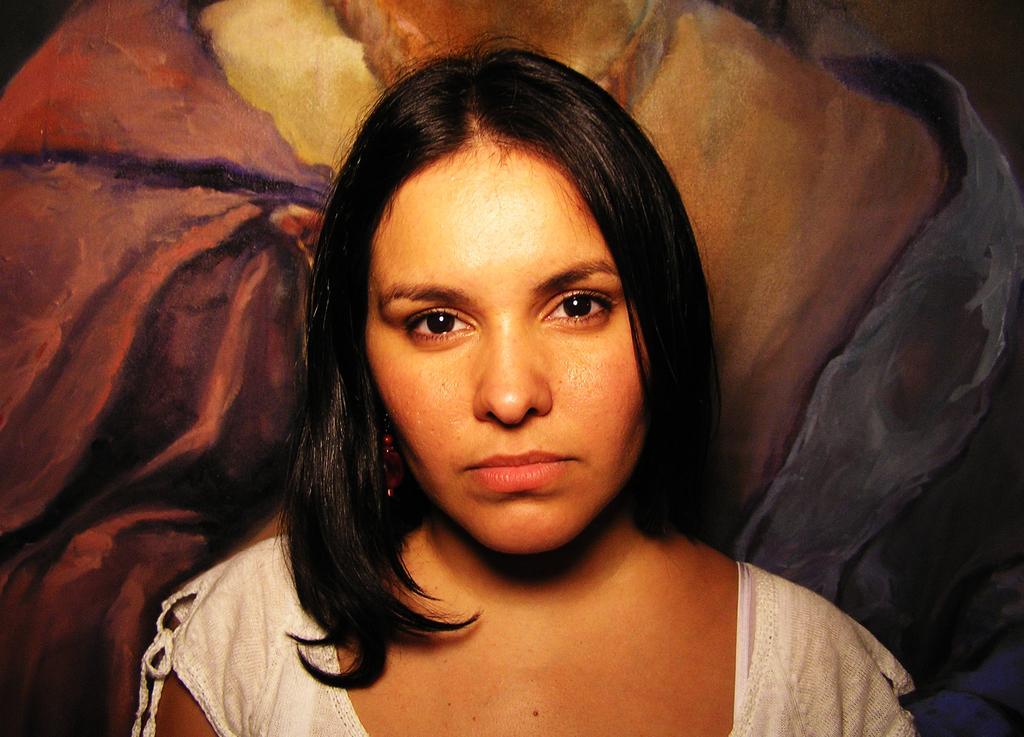Can you describe this image briefly? In this image there is a woman. Behind her there is a painting. 